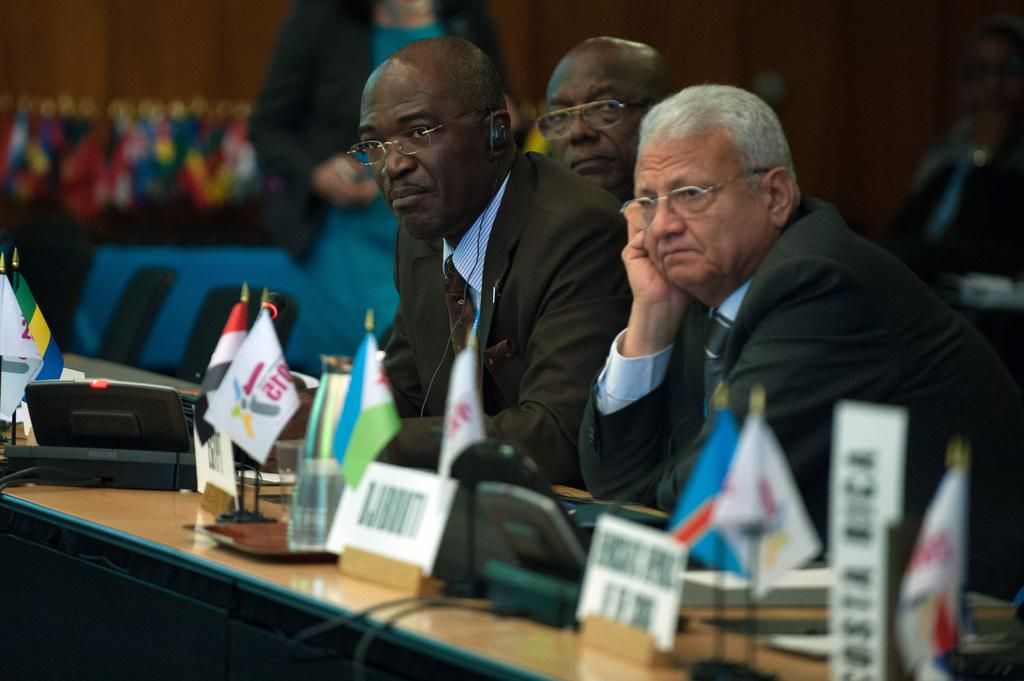What are the people in the image doing? The people in the image are sitting on chairs. What is in front of the chairs? There is a table in front of the chairs. What items can be seen on the table? Flags, glasses, and electrical items are on the table. How is the background of the image depicted? The background of the image is blurred. Can you tell me how many dogs are running in the background of the image? There are no dogs present in the image, and the background is blurred, so it is not possible to determine if any dogs are running. 